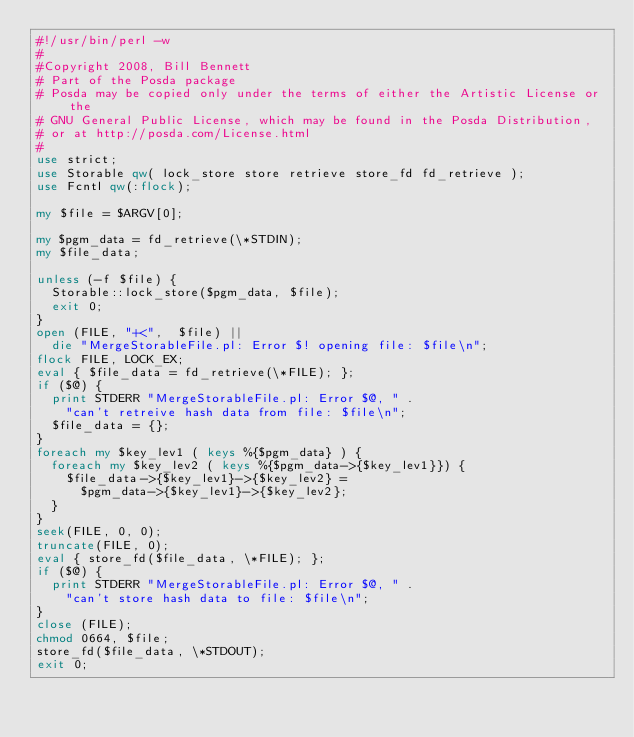<code> <loc_0><loc_0><loc_500><loc_500><_Perl_>#!/usr/bin/perl -w 
#
#Copyright 2008, Bill Bennett
# Part of the Posda package
# Posda may be copied only under the terms of either the Artistic License or the
# GNU General Public License, which may be found in the Posda Distribution,
# or at http://posda.com/License.html
#
use strict;
use Storable qw( lock_store store retrieve store_fd fd_retrieve );
use Fcntl qw(:flock);

my $file = $ARGV[0];

my $pgm_data = fd_retrieve(\*STDIN);
my $file_data;

unless (-f $file) {
  Storable::lock_store($pgm_data, $file);
  exit 0;
}
open (FILE, "+<",  $file) || 
  die "MergeStorableFile.pl: Error $! opening file: $file\n";
flock FILE, LOCK_EX;
eval { $file_data = fd_retrieve(\*FILE); };
if ($@) { 
  print STDERR "MergeStorableFile.pl: Error $@, " .
    "can't retreive hash data from file: $file\n";
  $file_data = {}; 
}
foreach my $key_lev1 ( keys %{$pgm_data} ) {
  foreach my $key_lev2 ( keys %{$pgm_data->{$key_lev1}}) {
    $file_data->{$key_lev1}->{$key_lev2} = 
      $pgm_data->{$key_lev1}->{$key_lev2};
  }
}
seek(FILE, 0, 0);
truncate(FILE, 0);
eval { store_fd($file_data, \*FILE); };
if ($@) {
  print STDERR "MergeStorableFile.pl: Error $@, " .
    "can't store hash data to file: $file\n";
}
close (FILE);
chmod 0664, $file;
store_fd($file_data, \*STDOUT);
exit 0;
</code> 